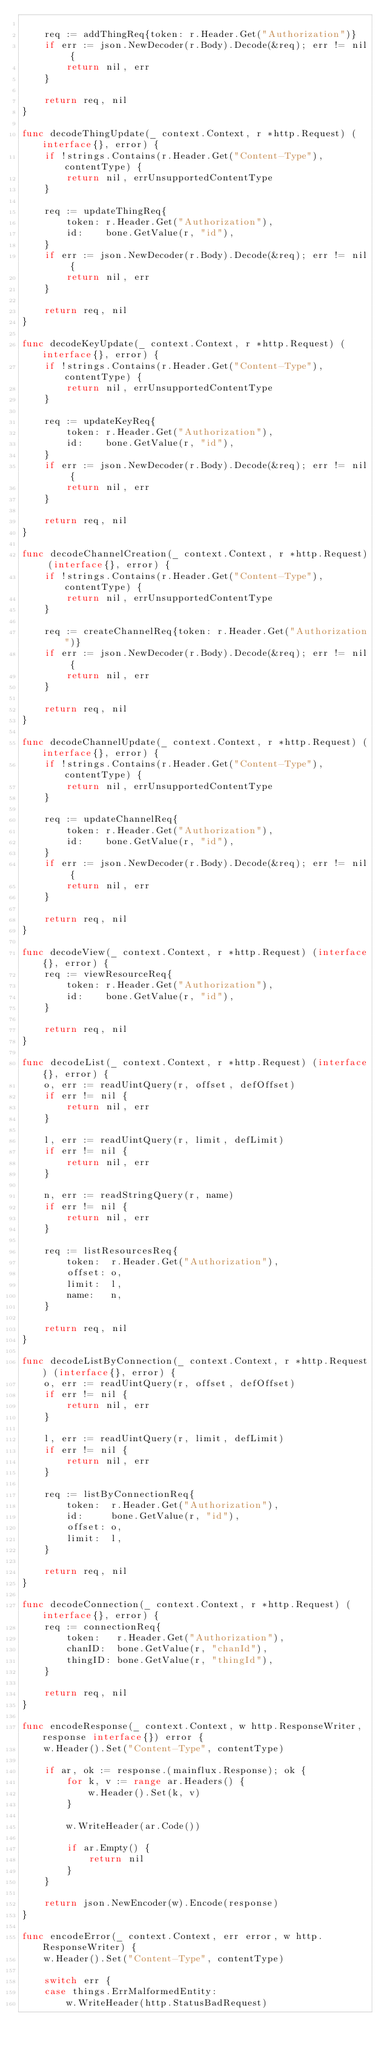<code> <loc_0><loc_0><loc_500><loc_500><_Go_>
	req := addThingReq{token: r.Header.Get("Authorization")}
	if err := json.NewDecoder(r.Body).Decode(&req); err != nil {
		return nil, err
	}

	return req, nil
}

func decodeThingUpdate(_ context.Context, r *http.Request) (interface{}, error) {
	if !strings.Contains(r.Header.Get("Content-Type"), contentType) {
		return nil, errUnsupportedContentType
	}

	req := updateThingReq{
		token: r.Header.Get("Authorization"),
		id:    bone.GetValue(r, "id"),
	}
	if err := json.NewDecoder(r.Body).Decode(&req); err != nil {
		return nil, err
	}

	return req, nil
}

func decodeKeyUpdate(_ context.Context, r *http.Request) (interface{}, error) {
	if !strings.Contains(r.Header.Get("Content-Type"), contentType) {
		return nil, errUnsupportedContentType
	}

	req := updateKeyReq{
		token: r.Header.Get("Authorization"),
		id:    bone.GetValue(r, "id"),
	}
	if err := json.NewDecoder(r.Body).Decode(&req); err != nil {
		return nil, err
	}

	return req, nil
}

func decodeChannelCreation(_ context.Context, r *http.Request) (interface{}, error) {
	if !strings.Contains(r.Header.Get("Content-Type"), contentType) {
		return nil, errUnsupportedContentType
	}

	req := createChannelReq{token: r.Header.Get("Authorization")}
	if err := json.NewDecoder(r.Body).Decode(&req); err != nil {
		return nil, err
	}

	return req, nil
}

func decodeChannelUpdate(_ context.Context, r *http.Request) (interface{}, error) {
	if !strings.Contains(r.Header.Get("Content-Type"), contentType) {
		return nil, errUnsupportedContentType
	}

	req := updateChannelReq{
		token: r.Header.Get("Authorization"),
		id:    bone.GetValue(r, "id"),
	}
	if err := json.NewDecoder(r.Body).Decode(&req); err != nil {
		return nil, err
	}

	return req, nil
}

func decodeView(_ context.Context, r *http.Request) (interface{}, error) {
	req := viewResourceReq{
		token: r.Header.Get("Authorization"),
		id:    bone.GetValue(r, "id"),
	}

	return req, nil
}

func decodeList(_ context.Context, r *http.Request) (interface{}, error) {
	o, err := readUintQuery(r, offset, defOffset)
	if err != nil {
		return nil, err
	}

	l, err := readUintQuery(r, limit, defLimit)
	if err != nil {
		return nil, err
	}

	n, err := readStringQuery(r, name)
	if err != nil {
		return nil, err
	}

	req := listResourcesReq{
		token:  r.Header.Get("Authorization"),
		offset: o,
		limit:  l,
		name:   n,
	}

	return req, nil
}

func decodeListByConnection(_ context.Context, r *http.Request) (interface{}, error) {
	o, err := readUintQuery(r, offset, defOffset)
	if err != nil {
		return nil, err
	}

	l, err := readUintQuery(r, limit, defLimit)
	if err != nil {
		return nil, err
	}

	req := listByConnectionReq{
		token:  r.Header.Get("Authorization"),
		id:     bone.GetValue(r, "id"),
		offset: o,
		limit:  l,
	}

	return req, nil
}

func decodeConnection(_ context.Context, r *http.Request) (interface{}, error) {
	req := connectionReq{
		token:   r.Header.Get("Authorization"),
		chanID:  bone.GetValue(r, "chanId"),
		thingID: bone.GetValue(r, "thingId"),
	}

	return req, nil
}

func encodeResponse(_ context.Context, w http.ResponseWriter, response interface{}) error {
	w.Header().Set("Content-Type", contentType)

	if ar, ok := response.(mainflux.Response); ok {
		for k, v := range ar.Headers() {
			w.Header().Set(k, v)
		}

		w.WriteHeader(ar.Code())

		if ar.Empty() {
			return nil
		}
	}

	return json.NewEncoder(w).Encode(response)
}

func encodeError(_ context.Context, err error, w http.ResponseWriter) {
	w.Header().Set("Content-Type", contentType)

	switch err {
	case things.ErrMalformedEntity:
		w.WriteHeader(http.StatusBadRequest)</code> 